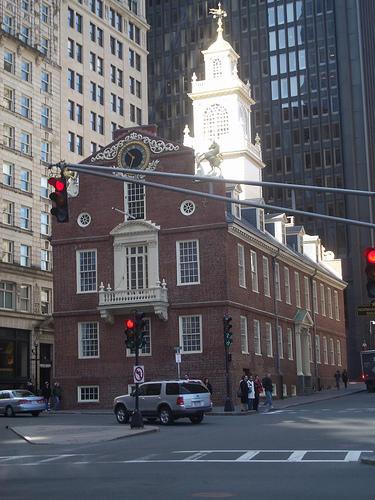What does the three matching lights indicate?
Give a very brief answer. Stop. How many stories is the building on the left?
Quick response, please. 12. What style of architecture best describes the brick building?
Keep it brief. Gothic. What is the color of the traffic light?
Quick response, please. Red. 